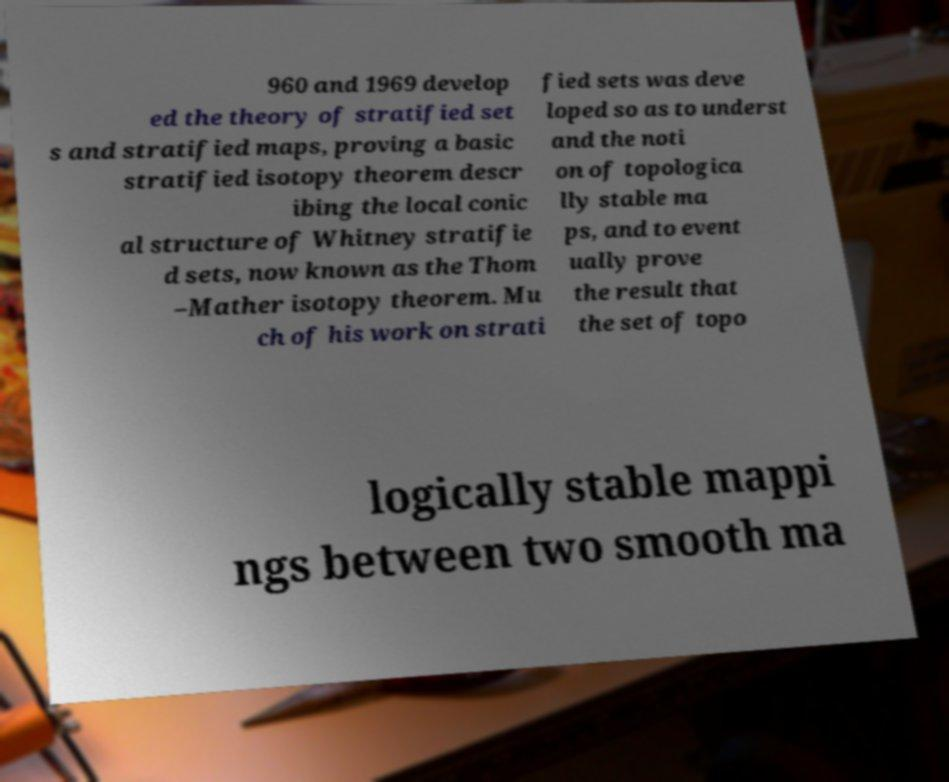For documentation purposes, I need the text within this image transcribed. Could you provide that? 960 and 1969 develop ed the theory of stratified set s and stratified maps, proving a basic stratified isotopy theorem descr ibing the local conic al structure of Whitney stratifie d sets, now known as the Thom –Mather isotopy theorem. Mu ch of his work on strati fied sets was deve loped so as to underst and the noti on of topologica lly stable ma ps, and to event ually prove the result that the set of topo logically stable mappi ngs between two smooth ma 